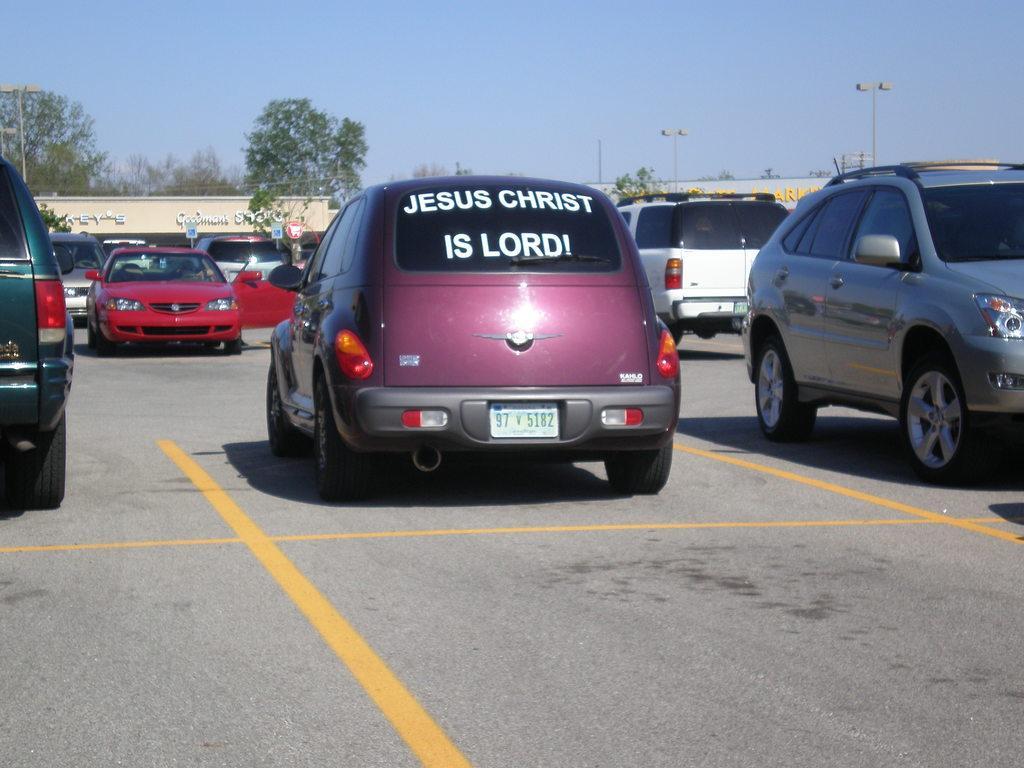Could you give a brief overview of what you see in this image? In this image I can see the ground and few vehicles which are red, white, grey and pink in color on the ground. In the background I can see few buildings, few trees, few poles and the sky. 